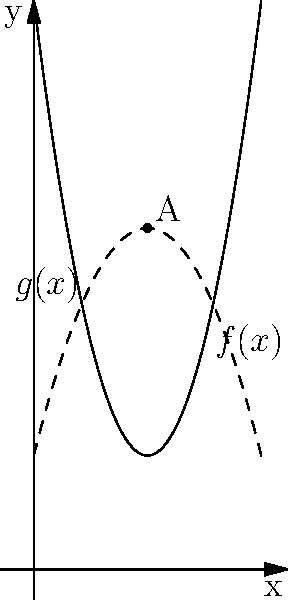In a city planning project, two potential green space layouts are represented by the functions $f(x) = 2x^2 - 8x + 10$ and $g(x) = -x^2 + 4x + 2$, where $x$ represents distance from the city center (in km) and $y$ represents the width of the green space (in 100m). At what distance from the city center do these two layouts intersect, and what is the width of the green space at this point? To find the intersection point of the two layouts, we need to solve the equation:

$f(x) = g(x)$

$2x^2 - 8x + 10 = -x^2 + 4x + 2$

Rearranging the terms:
$3x^2 - 12x + 8 = 0$

This is a quadratic equation. We can solve it using the quadratic formula:
$x = \frac{-b \pm \sqrt{b^2 - 4ac}}{2a}$

Where $a = 3$, $b = -12$, and $c = 8$

$x = \frac{12 \pm \sqrt{144 - 96}}{6} = \frac{12 \pm \sqrt{48}}{6} = \frac{12 \pm 4\sqrt{3}}{6}$

This gives us two solutions: $x_1 = 2 + \frac{2\sqrt{3}}{3}$ and $x_2 = 2 - \frac{2\sqrt{3}}{3}$

However, we're only interested in the positive solution within our domain, which is $x = 2$.

To find the width of the green space at this point, we can substitute $x = 2$ into either function:

$f(2) = 2(2)^2 - 8(2) + 10 = 8 - 16 + 10 = 2$

Therefore, the green space layouts intersect at a distance of 2 km from the city center, with a width of 200m (2 * 100m).
Answer: 2 km from city center, 200m wide 